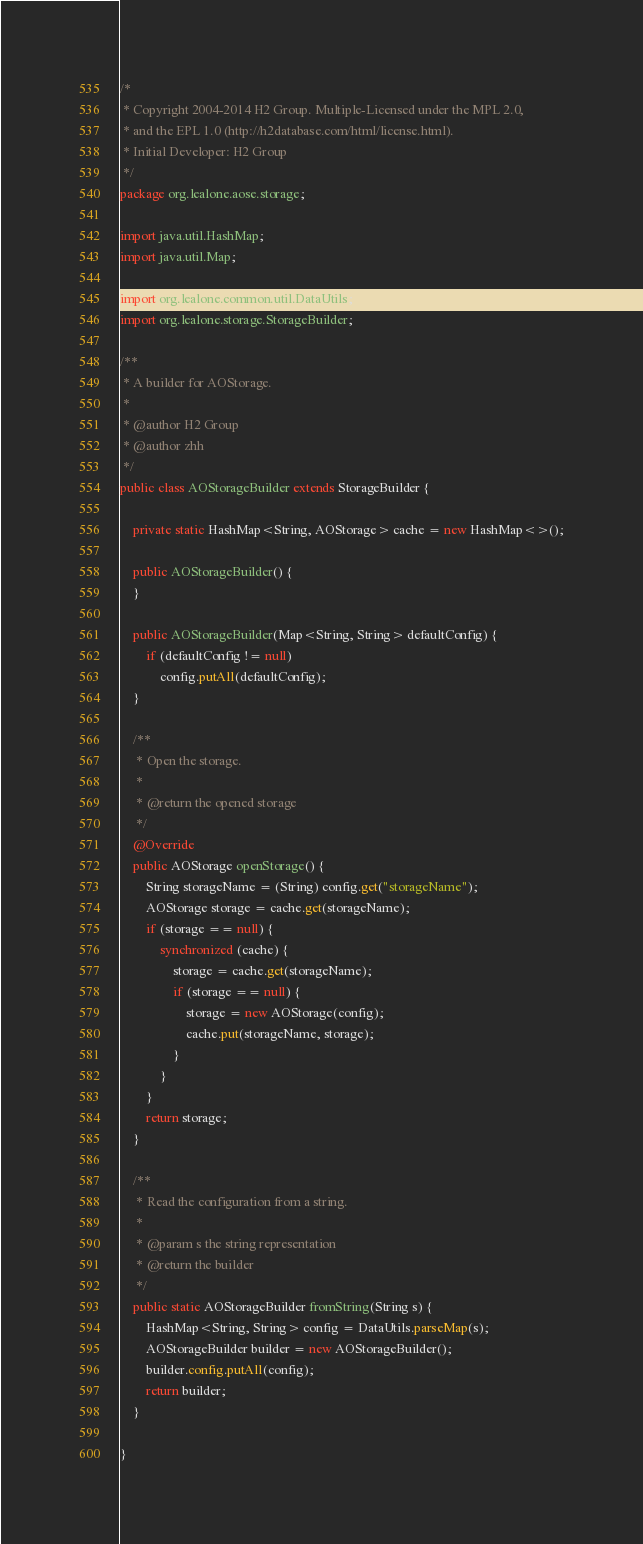Convert code to text. <code><loc_0><loc_0><loc_500><loc_500><_Java_>/*
 * Copyright 2004-2014 H2 Group. Multiple-Licensed under the MPL 2.0,
 * and the EPL 1.0 (http://h2database.com/html/license.html).
 * Initial Developer: H2 Group
 */
package org.lealone.aose.storage;

import java.util.HashMap;
import java.util.Map;

import org.lealone.common.util.DataUtils;
import org.lealone.storage.StorageBuilder;

/**
 * A builder for AOStorage.
 * 
 * @author H2 Group
 * @author zhh
 */
public class AOStorageBuilder extends StorageBuilder {

    private static HashMap<String, AOStorage> cache = new HashMap<>();

    public AOStorageBuilder() {
    }

    public AOStorageBuilder(Map<String, String> defaultConfig) {
        if (defaultConfig != null)
            config.putAll(defaultConfig);
    }

    /**
     * Open the storage.
     * 
     * @return the opened storage
     */
    @Override
    public AOStorage openStorage() {
        String storageName = (String) config.get("storageName");
        AOStorage storage = cache.get(storageName);
        if (storage == null) {
            synchronized (cache) {
                storage = cache.get(storageName);
                if (storage == null) {
                    storage = new AOStorage(config);
                    cache.put(storageName, storage);
                }
            }
        }
        return storage;
    }

    /**
     * Read the configuration from a string.
     * 
     * @param s the string representation
     * @return the builder
     */
    public static AOStorageBuilder fromString(String s) {
        HashMap<String, String> config = DataUtils.parseMap(s);
        AOStorageBuilder builder = new AOStorageBuilder();
        builder.config.putAll(config);
        return builder;
    }

}
</code> 